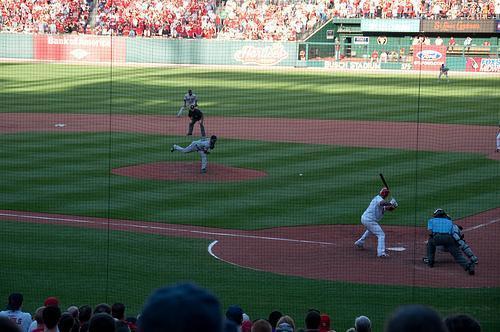How many baseballs are visible?
Give a very brief answer. 1. 